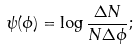<formula> <loc_0><loc_0><loc_500><loc_500>\psi ( \phi ) = \log \frac { \Delta N } { N \Delta \phi } ;</formula> 